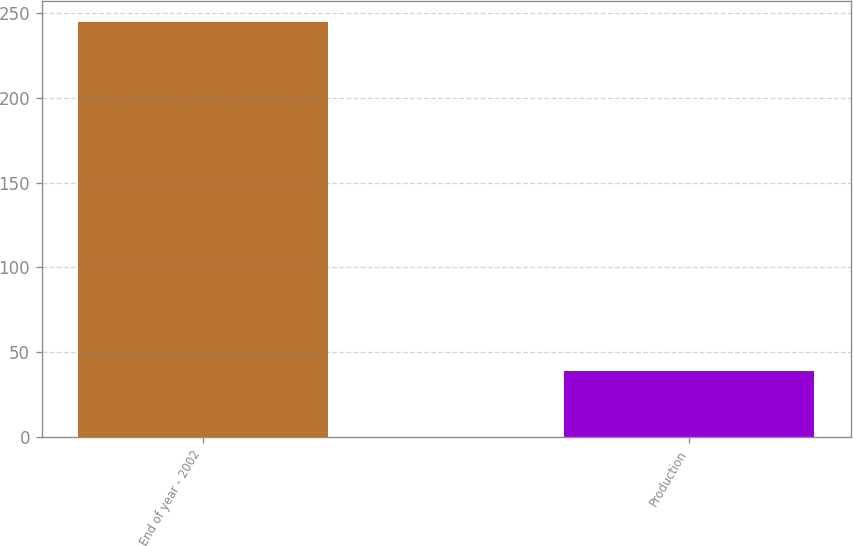<chart> <loc_0><loc_0><loc_500><loc_500><bar_chart><fcel>End of year - 2002<fcel>Production<nl><fcel>245<fcel>39<nl></chart> 